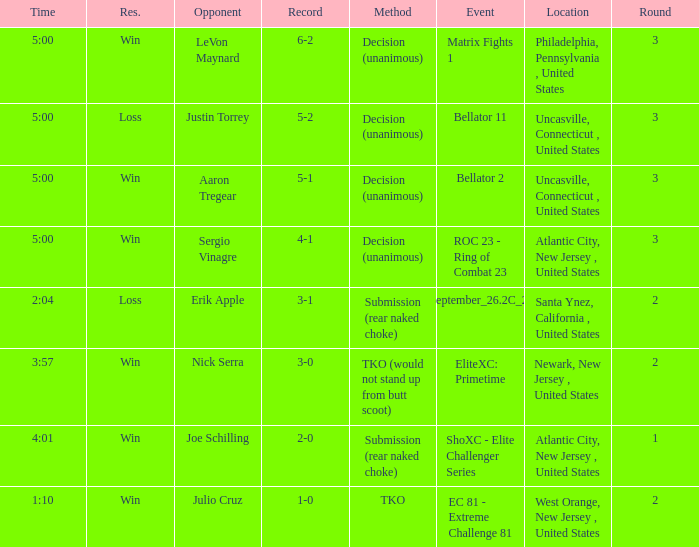What round was it when the method was TKO (would not stand up from Butt Scoot)? 2.0. 